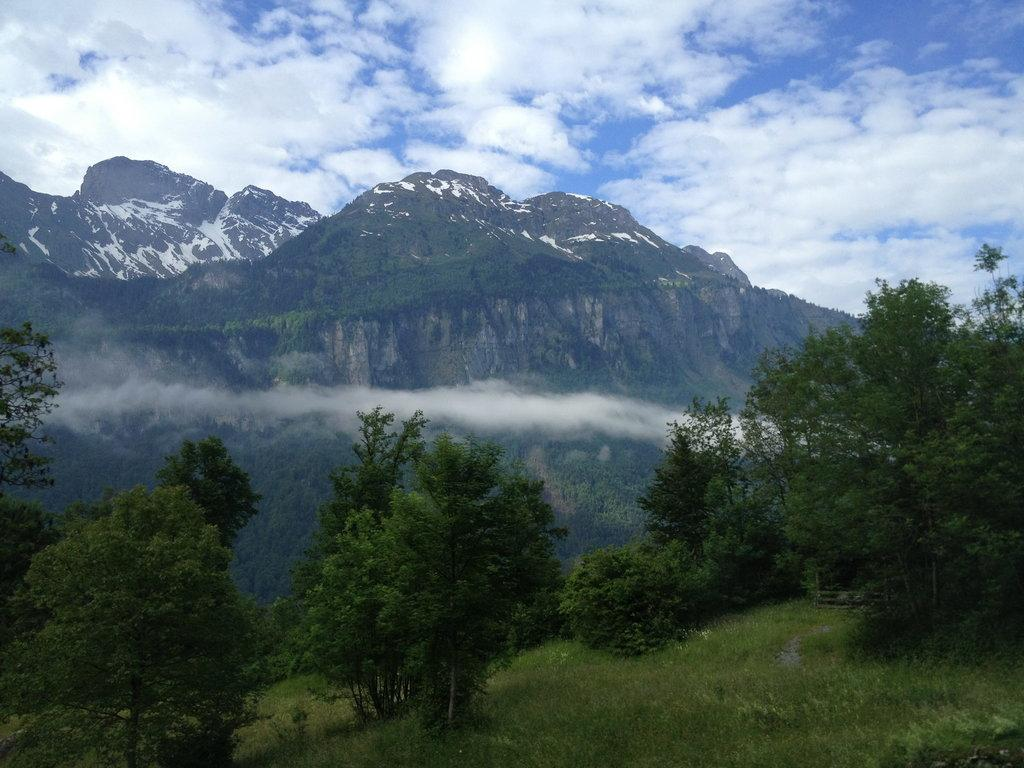What type of vegetation can be seen in the image? There are trees and grass in the image. What can be seen in the background of the image? There are mountains, clouds, and a blue sky in the background of the image. Is there a building visible in the image? No, there is no building present in the image. What type of connection can be seen between the trees and the grass in the image? There is no connection between the trees and the grass mentioned in the image; they are simply different types of vegetation. 